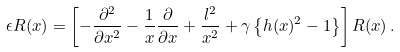Convert formula to latex. <formula><loc_0><loc_0><loc_500><loc_500>\epsilon R ( x ) = \left [ - \frac { \partial ^ { 2 } } { \partial x ^ { 2 } } - \frac { 1 } { x } \frac { \partial } { \partial x } + \frac { l ^ { 2 } } { x ^ { 2 } } + \gamma \left \{ h ( x ) ^ { 2 } - 1 \right \} \right ] R ( x ) \, .</formula> 